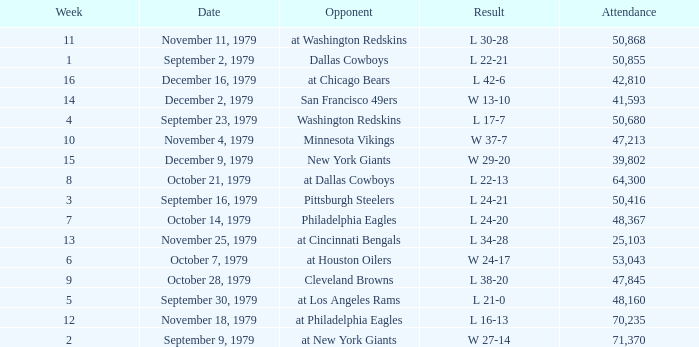What is the highest week when attendance is greater than 64,300 with a result of w 27-14? 2.0. 